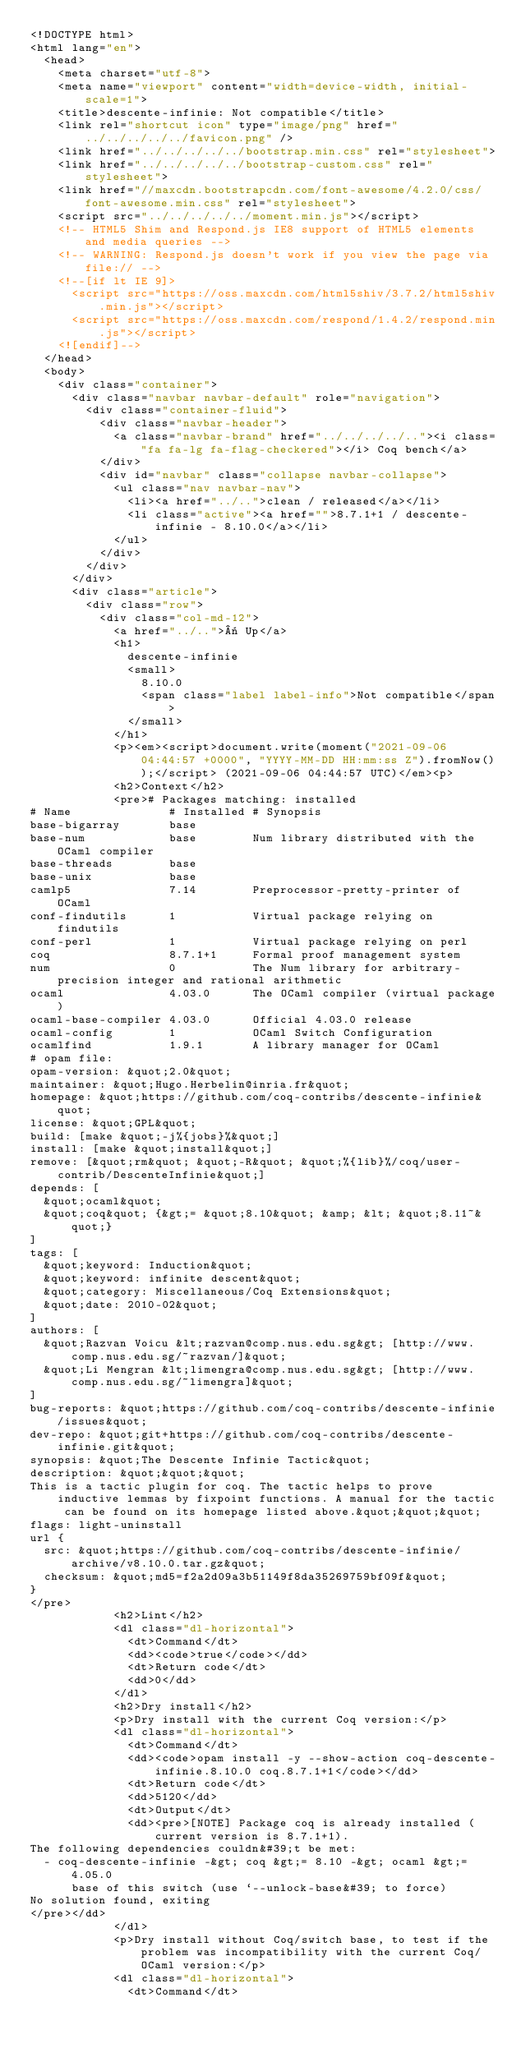<code> <loc_0><loc_0><loc_500><loc_500><_HTML_><!DOCTYPE html>
<html lang="en">
  <head>
    <meta charset="utf-8">
    <meta name="viewport" content="width=device-width, initial-scale=1">
    <title>descente-infinie: Not compatible</title>
    <link rel="shortcut icon" type="image/png" href="../../../../../favicon.png" />
    <link href="../../../../../bootstrap.min.css" rel="stylesheet">
    <link href="../../../../../bootstrap-custom.css" rel="stylesheet">
    <link href="//maxcdn.bootstrapcdn.com/font-awesome/4.2.0/css/font-awesome.min.css" rel="stylesheet">
    <script src="../../../../../moment.min.js"></script>
    <!-- HTML5 Shim and Respond.js IE8 support of HTML5 elements and media queries -->
    <!-- WARNING: Respond.js doesn't work if you view the page via file:// -->
    <!--[if lt IE 9]>
      <script src="https://oss.maxcdn.com/html5shiv/3.7.2/html5shiv.min.js"></script>
      <script src="https://oss.maxcdn.com/respond/1.4.2/respond.min.js"></script>
    <![endif]-->
  </head>
  <body>
    <div class="container">
      <div class="navbar navbar-default" role="navigation">
        <div class="container-fluid">
          <div class="navbar-header">
            <a class="navbar-brand" href="../../../../.."><i class="fa fa-lg fa-flag-checkered"></i> Coq bench</a>
          </div>
          <div id="navbar" class="collapse navbar-collapse">
            <ul class="nav navbar-nav">
              <li><a href="../..">clean / released</a></li>
              <li class="active"><a href="">8.7.1+1 / descente-infinie - 8.10.0</a></li>
            </ul>
          </div>
        </div>
      </div>
      <div class="article">
        <div class="row">
          <div class="col-md-12">
            <a href="../..">« Up</a>
            <h1>
              descente-infinie
              <small>
                8.10.0
                <span class="label label-info">Not compatible</span>
              </small>
            </h1>
            <p><em><script>document.write(moment("2021-09-06 04:44:57 +0000", "YYYY-MM-DD HH:mm:ss Z").fromNow());</script> (2021-09-06 04:44:57 UTC)</em><p>
            <h2>Context</h2>
            <pre># Packages matching: installed
# Name              # Installed # Synopsis
base-bigarray       base
base-num            base        Num library distributed with the OCaml compiler
base-threads        base
base-unix           base
camlp5              7.14        Preprocessor-pretty-printer of OCaml
conf-findutils      1           Virtual package relying on findutils
conf-perl           1           Virtual package relying on perl
coq                 8.7.1+1     Formal proof management system
num                 0           The Num library for arbitrary-precision integer and rational arithmetic
ocaml               4.03.0      The OCaml compiler (virtual package)
ocaml-base-compiler 4.03.0      Official 4.03.0 release
ocaml-config        1           OCaml Switch Configuration
ocamlfind           1.9.1       A library manager for OCaml
# opam file:
opam-version: &quot;2.0&quot;
maintainer: &quot;Hugo.Herbelin@inria.fr&quot;
homepage: &quot;https://github.com/coq-contribs/descente-infinie&quot;
license: &quot;GPL&quot;
build: [make &quot;-j%{jobs}%&quot;]
install: [make &quot;install&quot;]
remove: [&quot;rm&quot; &quot;-R&quot; &quot;%{lib}%/coq/user-contrib/DescenteInfinie&quot;]
depends: [
  &quot;ocaml&quot;
  &quot;coq&quot; {&gt;= &quot;8.10&quot; &amp; &lt; &quot;8.11~&quot;}
]
tags: [
  &quot;keyword: Induction&quot;
  &quot;keyword: infinite descent&quot;
  &quot;category: Miscellaneous/Coq Extensions&quot;
  &quot;date: 2010-02&quot;
]
authors: [
  &quot;Razvan Voicu &lt;razvan@comp.nus.edu.sg&gt; [http://www.comp.nus.edu.sg/~razvan/]&quot;
  &quot;Li Mengran &lt;limengra@comp.nus.edu.sg&gt; [http://www.comp.nus.edu.sg/~limengra]&quot;
]
bug-reports: &quot;https://github.com/coq-contribs/descente-infinie/issues&quot;
dev-repo: &quot;git+https://github.com/coq-contribs/descente-infinie.git&quot;
synopsis: &quot;The Descente Infinie Tactic&quot;
description: &quot;&quot;&quot;
This is a tactic plugin for coq. The tactic helps to prove inductive lemmas by fixpoint functions. A manual for the tactic can be found on its homepage listed above.&quot;&quot;&quot;
flags: light-uninstall
url {
  src: &quot;https://github.com/coq-contribs/descente-infinie/archive/v8.10.0.tar.gz&quot;
  checksum: &quot;md5=f2a2d09a3b51149f8da35269759bf09f&quot;
}
</pre>
            <h2>Lint</h2>
            <dl class="dl-horizontal">
              <dt>Command</dt>
              <dd><code>true</code></dd>
              <dt>Return code</dt>
              <dd>0</dd>
            </dl>
            <h2>Dry install</h2>
            <p>Dry install with the current Coq version:</p>
            <dl class="dl-horizontal">
              <dt>Command</dt>
              <dd><code>opam install -y --show-action coq-descente-infinie.8.10.0 coq.8.7.1+1</code></dd>
              <dt>Return code</dt>
              <dd>5120</dd>
              <dt>Output</dt>
              <dd><pre>[NOTE] Package coq is already installed (current version is 8.7.1+1).
The following dependencies couldn&#39;t be met:
  - coq-descente-infinie -&gt; coq &gt;= 8.10 -&gt; ocaml &gt;= 4.05.0
      base of this switch (use `--unlock-base&#39; to force)
No solution found, exiting
</pre></dd>
            </dl>
            <p>Dry install without Coq/switch base, to test if the problem was incompatibility with the current Coq/OCaml version:</p>
            <dl class="dl-horizontal">
              <dt>Command</dt></code> 